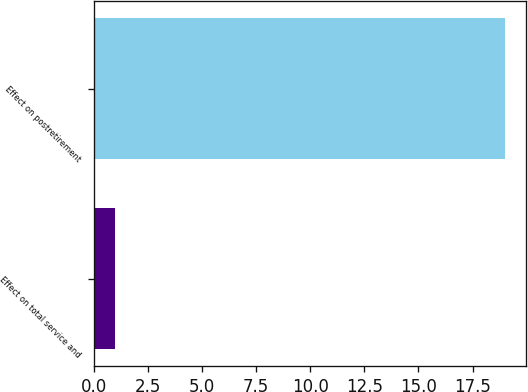Convert chart to OTSL. <chart><loc_0><loc_0><loc_500><loc_500><bar_chart><fcel>Effect on total service and<fcel>Effect on postretirement<nl><fcel>1<fcel>19<nl></chart> 